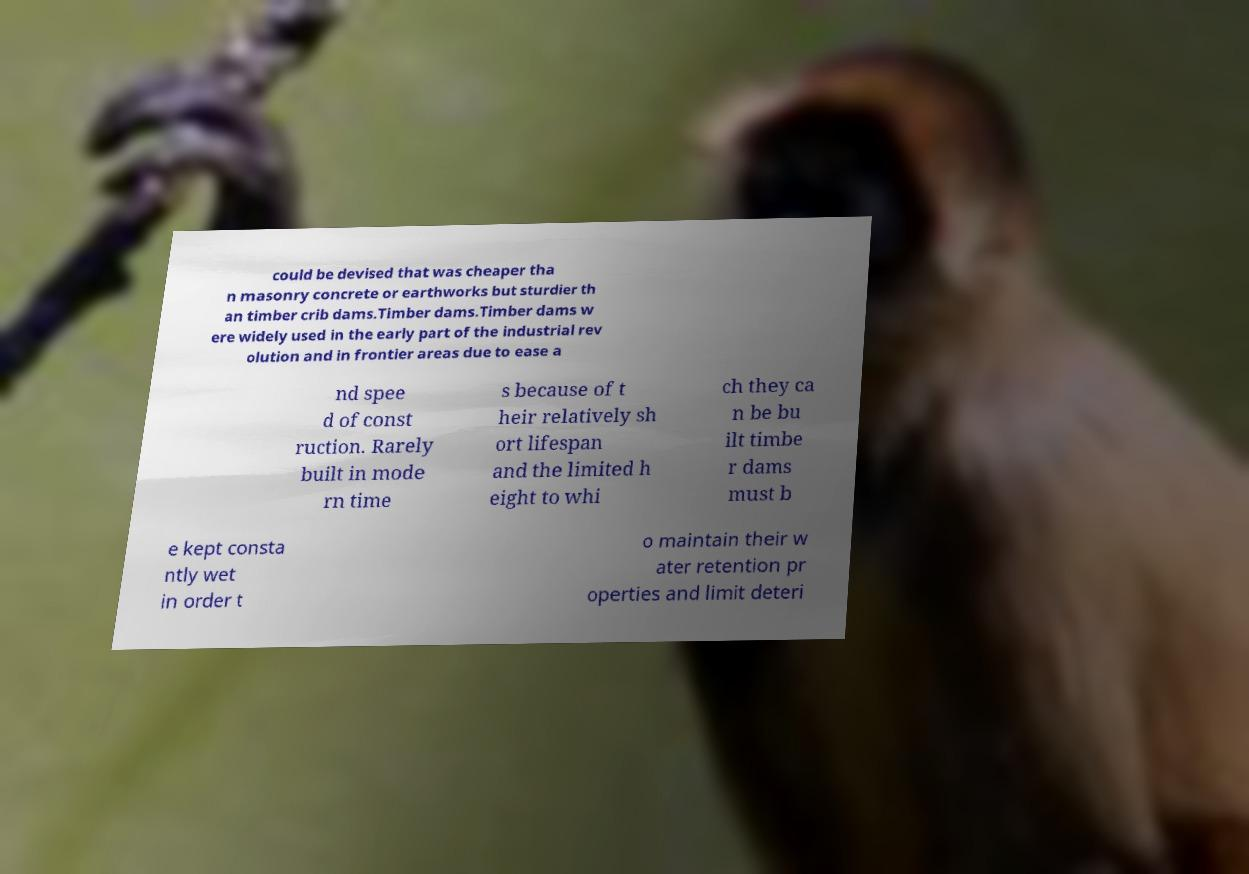Please identify and transcribe the text found in this image. could be devised that was cheaper tha n masonry concrete or earthworks but sturdier th an timber crib dams.Timber dams.Timber dams w ere widely used in the early part of the industrial rev olution and in frontier areas due to ease a nd spee d of const ruction. Rarely built in mode rn time s because of t heir relatively sh ort lifespan and the limited h eight to whi ch they ca n be bu ilt timbe r dams must b e kept consta ntly wet in order t o maintain their w ater retention pr operties and limit deteri 